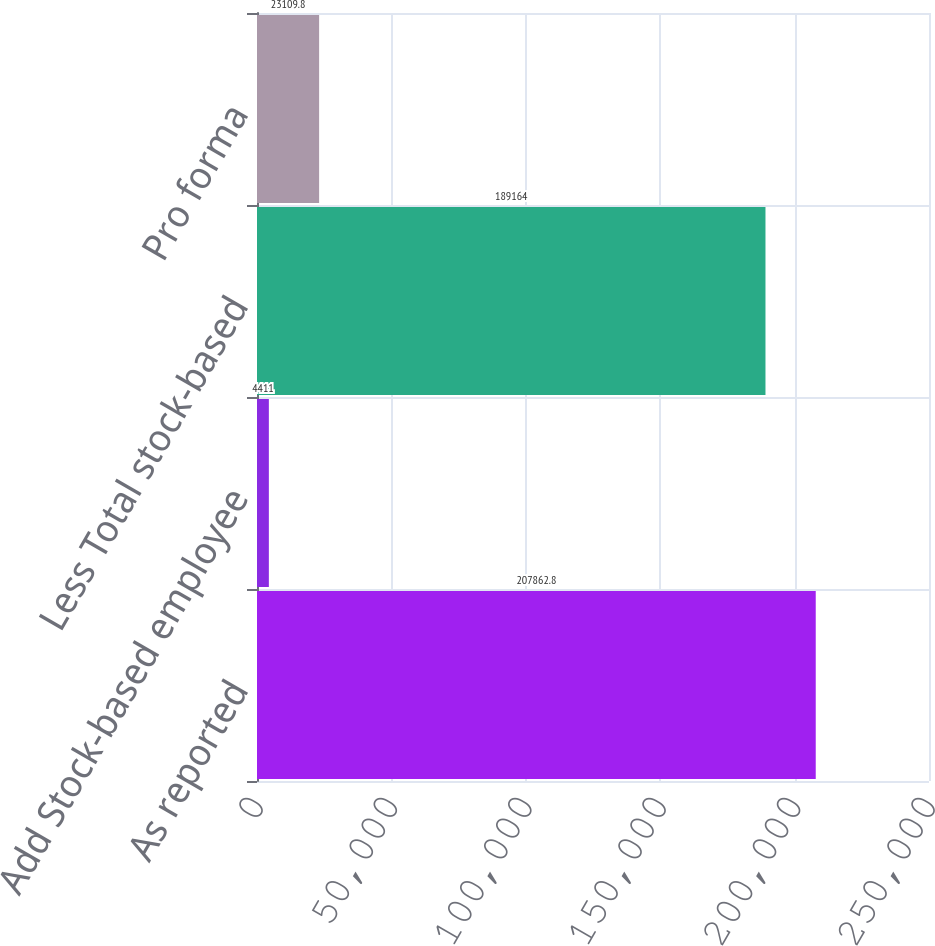<chart> <loc_0><loc_0><loc_500><loc_500><bar_chart><fcel>As reported<fcel>Add Stock-based employee<fcel>Less Total stock-based<fcel>Pro forma<nl><fcel>207863<fcel>4411<fcel>189164<fcel>23109.8<nl></chart> 